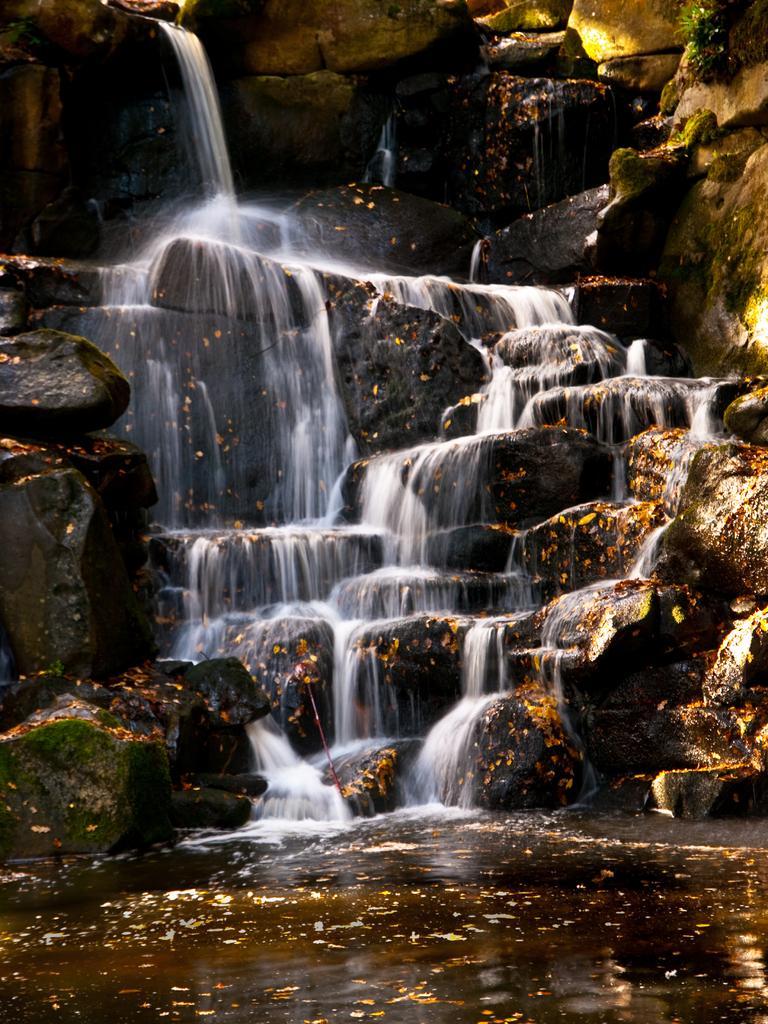How would you summarize this image in a sentence or two? In the foreground we can see the water. Here we can see the waterfall. Here we can see the rocks. 